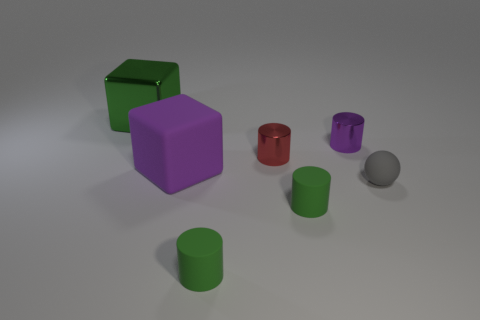How many green cylinders must be subtracted to get 1 green cylinders? 1 Add 1 large red metallic objects. How many objects exist? 8 Subtract all cubes. How many objects are left? 5 Add 4 large green cubes. How many large green cubes are left? 5 Add 3 green metallic objects. How many green metallic objects exist? 4 Subtract 1 purple cubes. How many objects are left? 6 Subtract all big cyan balls. Subtract all small red cylinders. How many objects are left? 6 